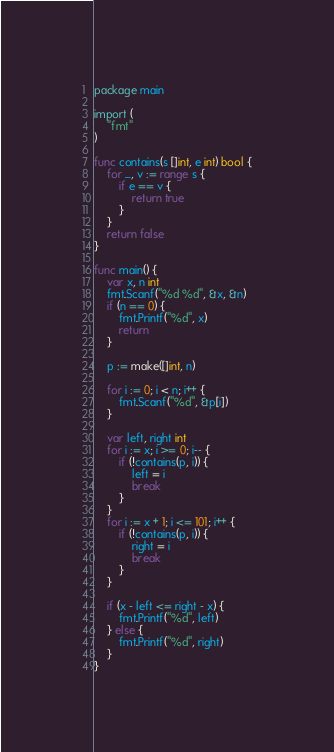Convert code to text. <code><loc_0><loc_0><loc_500><loc_500><_Go_>package main

import (
	"fmt"
)

func contains(s []int, e int) bool {
	for _, v := range s {
		if e == v {
			return true
		}
	}
	return false
}

func main() {
	var x, n int
	fmt.Scanf("%d %d", &x, &n)
	if (n == 0) {
		fmt.Printf("%d", x)
		return
	}

	p := make([]int, n)

	for i := 0; i < n; i++ {
		fmt.Scanf("%d", &p[i])
	}

	var left, right int
	for i := x; i >= 0; i-- {
		if (!contains(p, i)) {
			left = i
			break
		}
	}
	for i := x + 1; i <= 101; i++ {
		if (!contains(p, i)) {
			right = i
			break
		}
	}

	if (x - left <= right - x) {
		fmt.Printf("%d", left)
	} else {
		fmt.Printf("%d", right)
	}
}
</code> 